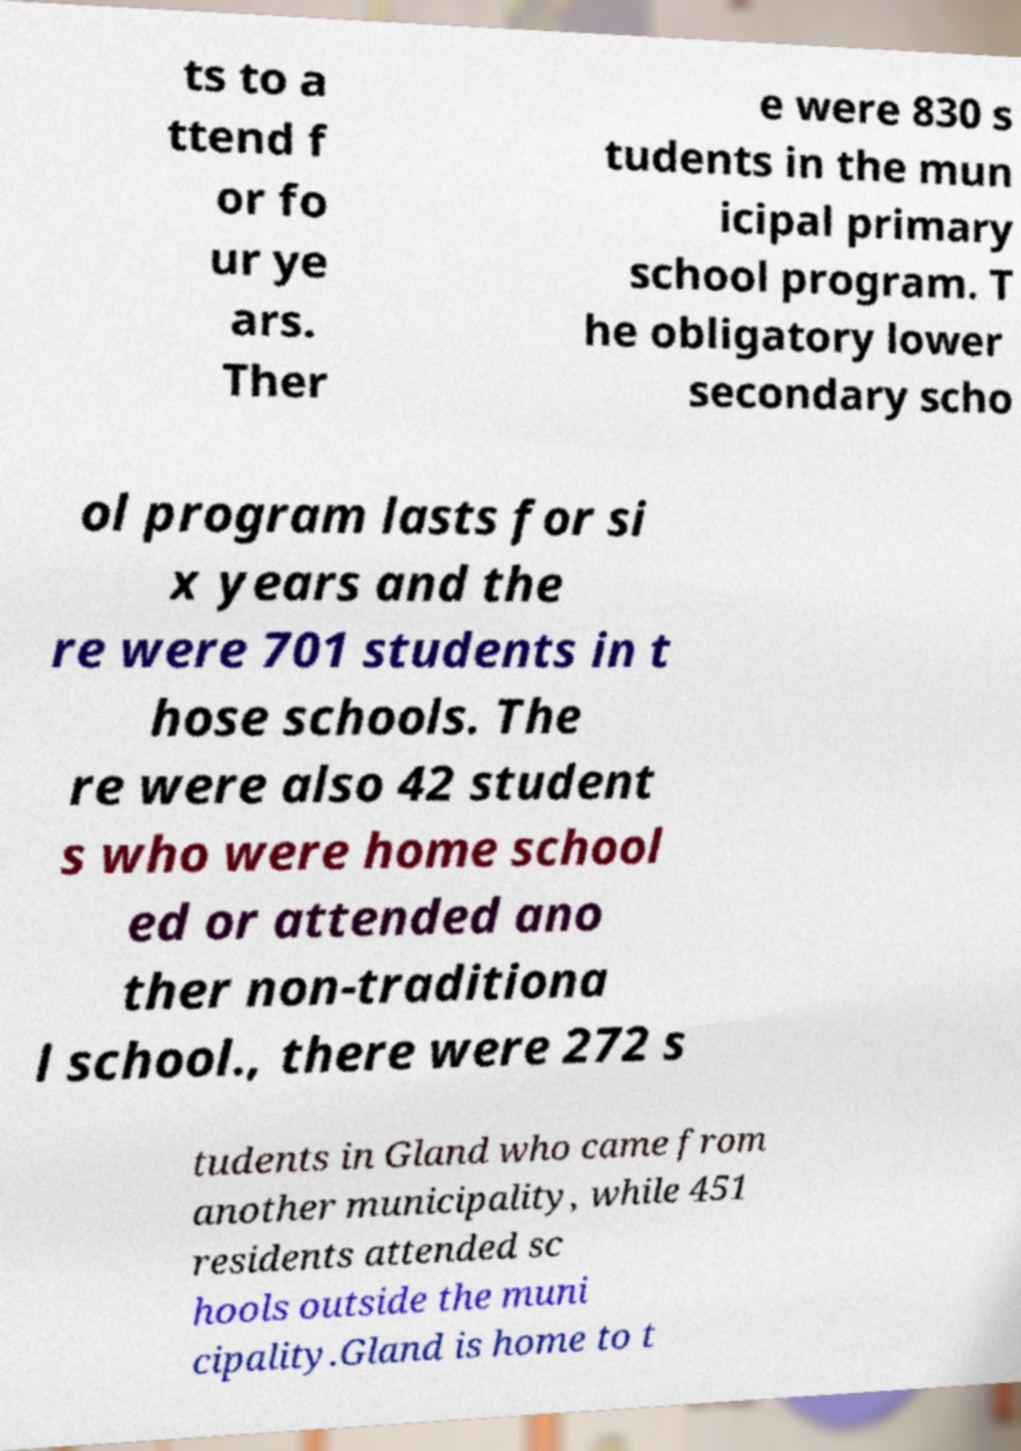What messages or text are displayed in this image? I need them in a readable, typed format. ts to a ttend f or fo ur ye ars. Ther e were 830 s tudents in the mun icipal primary school program. T he obligatory lower secondary scho ol program lasts for si x years and the re were 701 students in t hose schools. The re were also 42 student s who were home school ed or attended ano ther non-traditiona l school., there were 272 s tudents in Gland who came from another municipality, while 451 residents attended sc hools outside the muni cipality.Gland is home to t 